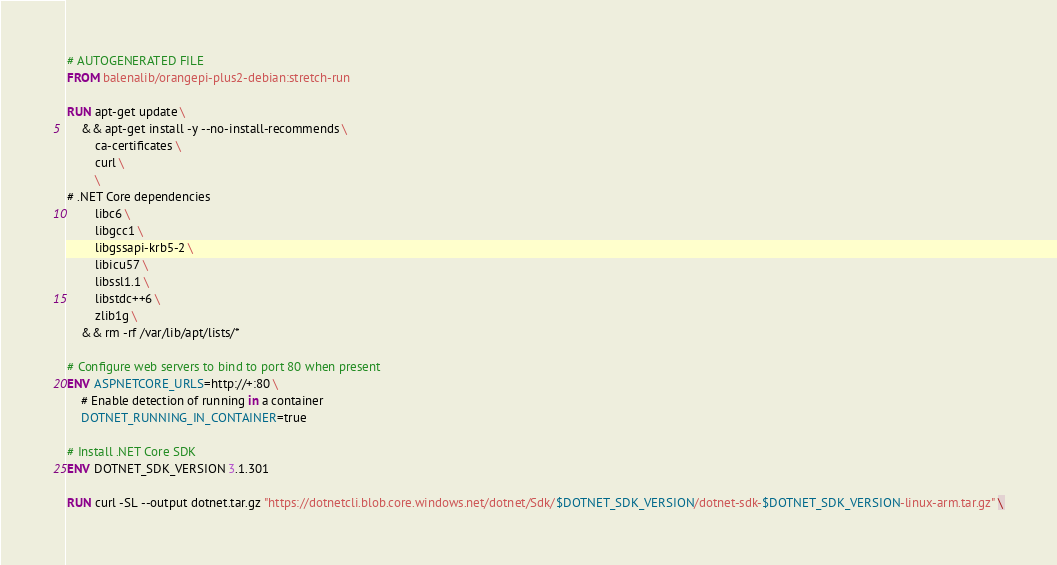<code> <loc_0><loc_0><loc_500><loc_500><_Dockerfile_># AUTOGENERATED FILE
FROM balenalib/orangepi-plus2-debian:stretch-run

RUN apt-get update \
    && apt-get install -y --no-install-recommends \
        ca-certificates \
        curl \
        \
# .NET Core dependencies
        libc6 \
        libgcc1 \
        libgssapi-krb5-2 \
        libicu57 \
        libssl1.1 \
        libstdc++6 \
        zlib1g \
    && rm -rf /var/lib/apt/lists/*

# Configure web servers to bind to port 80 when present
ENV ASPNETCORE_URLS=http://+:80 \
    # Enable detection of running in a container
    DOTNET_RUNNING_IN_CONTAINER=true

# Install .NET Core SDK
ENV DOTNET_SDK_VERSION 3.1.301

RUN curl -SL --output dotnet.tar.gz "https://dotnetcli.blob.core.windows.net/dotnet/Sdk/$DOTNET_SDK_VERSION/dotnet-sdk-$DOTNET_SDK_VERSION-linux-arm.tar.gz" \</code> 